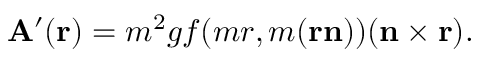<formula> <loc_0><loc_0><loc_500><loc_500>{ A } ^ { \prime } ( { r } ) = m ^ { 2 } g f ( m r , m ( { r } { n } ) ) ( { n } \times { r } ) .</formula> 